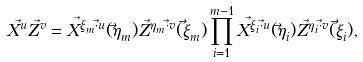<formula> <loc_0><loc_0><loc_500><loc_500>X ^ { \vec { u } } Z ^ { \vec { v } } = X ^ { \vec { \xi } _ { m } \cdot \vec { u } } ( \vec { \eta } _ { m } ) Z ^ { \vec { \eta } _ { m } \cdot \vec { v } } ( \vec { \xi } _ { m } ) \prod _ { i = 1 } ^ { m - 1 } X ^ { \vec { \xi } _ { i } \cdot \vec { u } } ( \vec { \eta } _ { i } ) Z ^ { \vec { \eta } _ { i } \cdot \vec { v } } ( \vec { \xi } _ { i } ) ,</formula> 